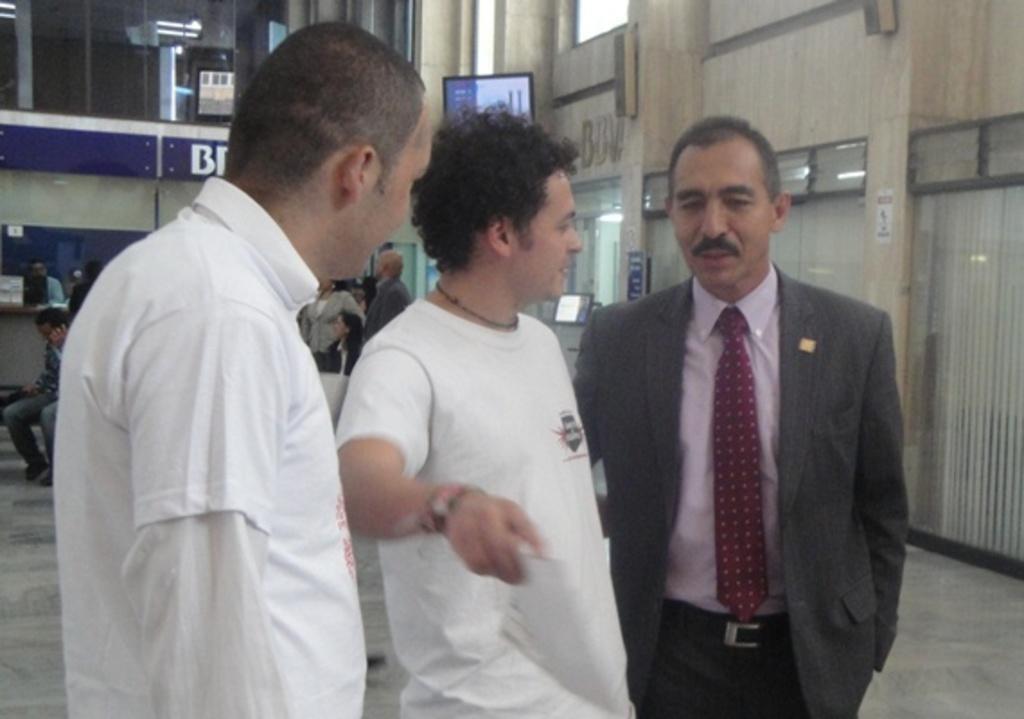In one or two sentences, can you explain what this image depicts? In the image there is a man with pink shirt and suit standing on the right side, beside him there are two men standing in white dress, this seems to be clicked inside building, on the right side back there is wall with windows on it, in the back there are few people standing and sitting and it seems to be a store on left side background. 